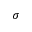Convert formula to latex. <formula><loc_0><loc_0><loc_500><loc_500>\sigma</formula> 